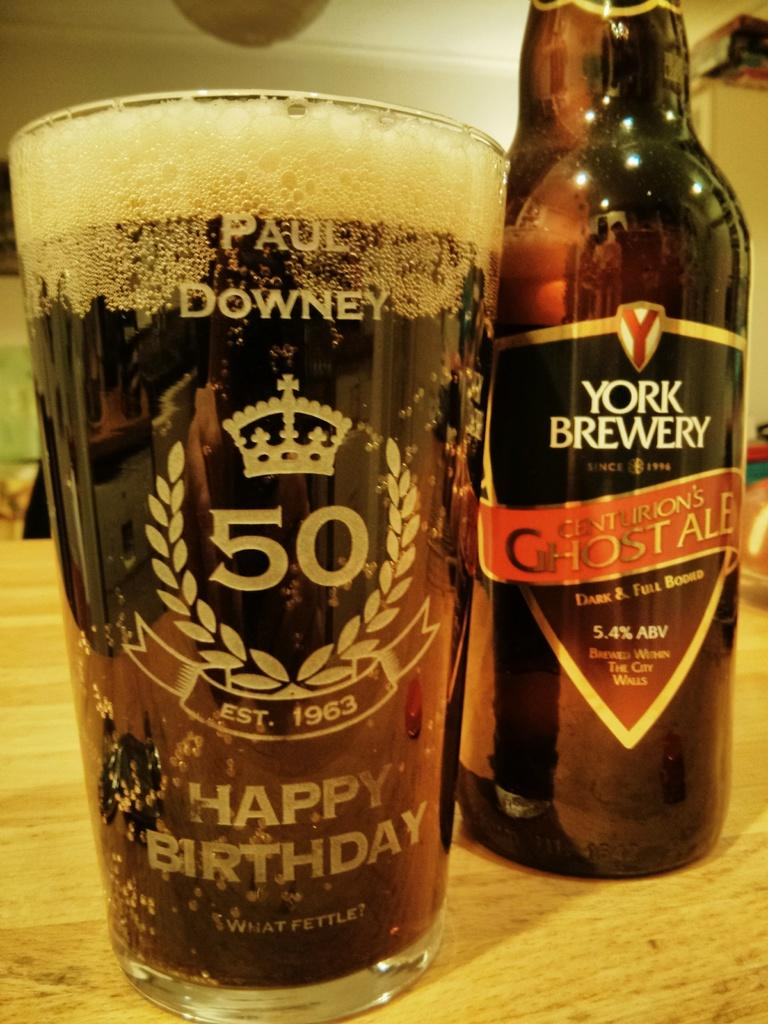<image>
Write a terse but informative summary of the picture. a bottle of york brewery labeled as centurions ghost ale 